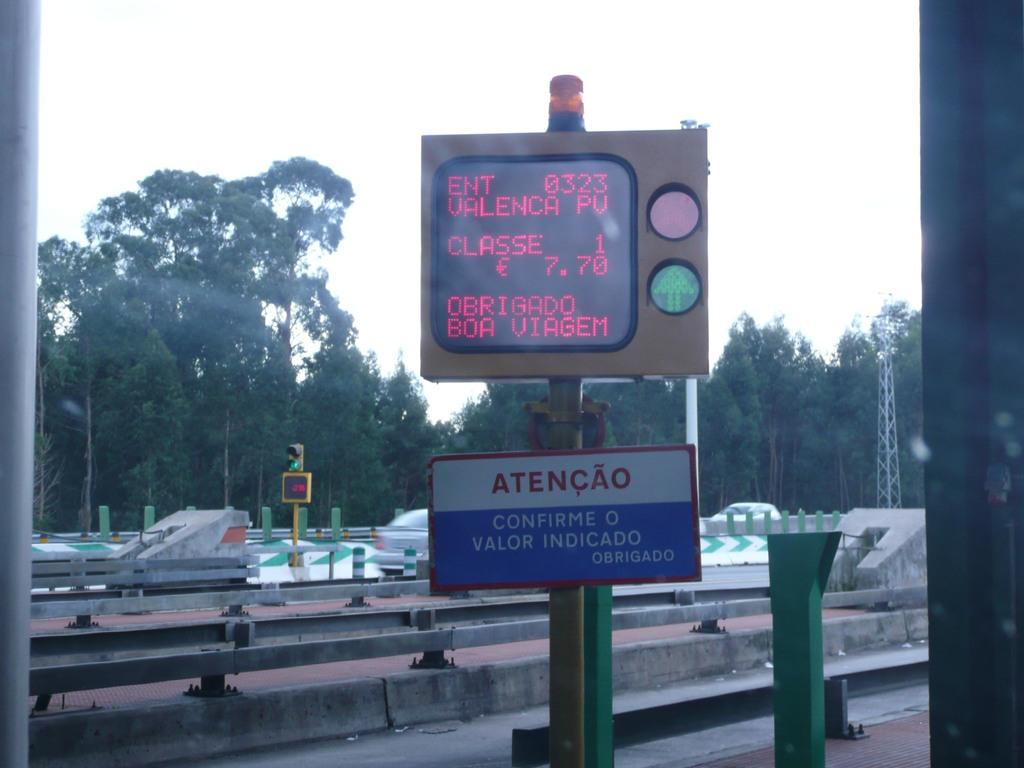What is located in the foreground of the image? There is a board and a traffic pole in the foreground of the image. What can be seen on either side of the image? There are poles on either side of the image. What is visible in the background of the image? There are railings, trees, and the sky visible in the background of the image. Can you see a nest of fish on the slope in the image? There is no nest of fish on a slope present in the image. 